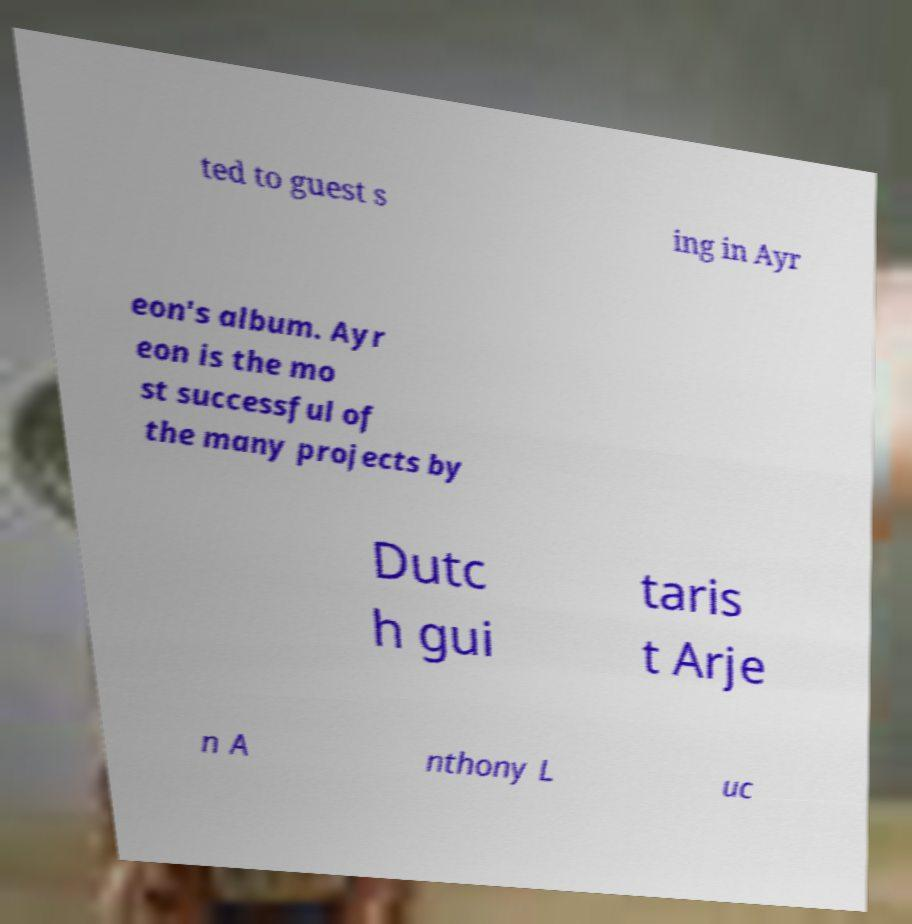There's text embedded in this image that I need extracted. Can you transcribe it verbatim? ted to guest s ing in Ayr eon's album. Ayr eon is the mo st successful of the many projects by Dutc h gui taris t Arje n A nthony L uc 